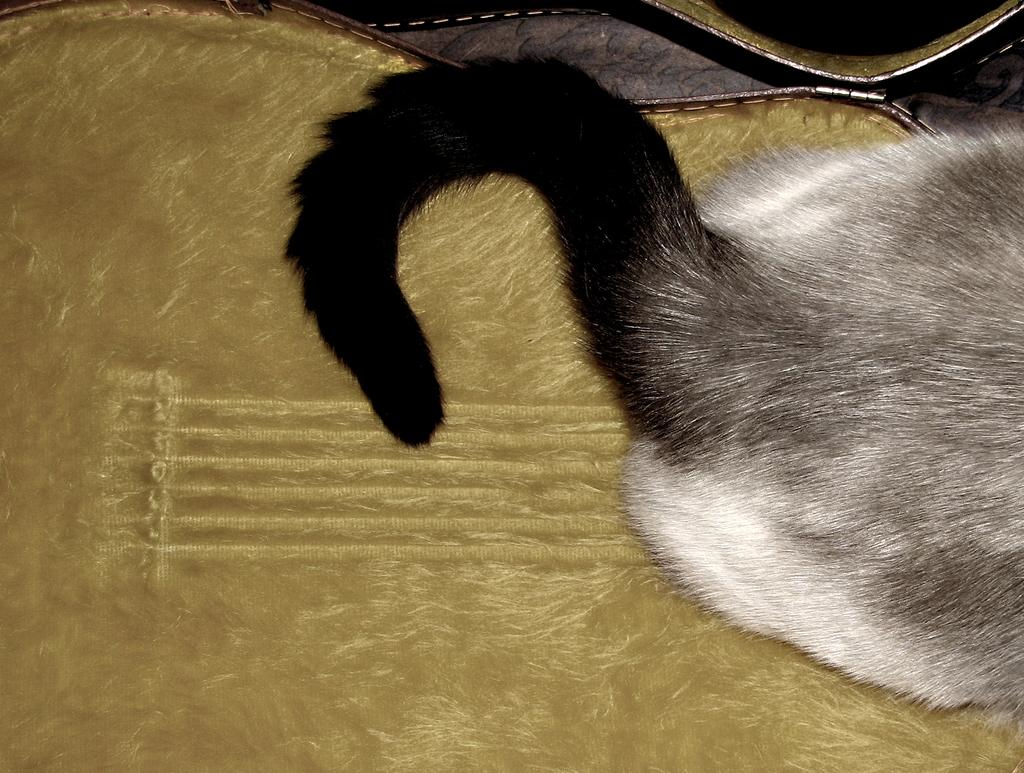What type of animal is in the image? There is an animal in the image, but the specific type cannot be determined from the provided facts. What is the animal standing on in the image? The animal is on a guitar-shaped mat in the image. Can you describe the item in the background of the image? Unfortunately, the provided facts do not give enough information to describe the item in the background. What type of grass is the animal grazing on in the image? There is no grass present in the image; the animal is standing on a guitar-shaped mat. Can you describe the skateboarding tricks the animal is performing in the image? There is no skateboard or any indication of skateboarding in the image. 